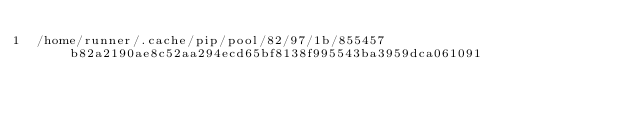<code> <loc_0><loc_0><loc_500><loc_500><_Python_>/home/runner/.cache/pip/pool/82/97/1b/855457b82a2190ae8c52aa294ecd65bf8138f995543ba3959dca061091</code> 